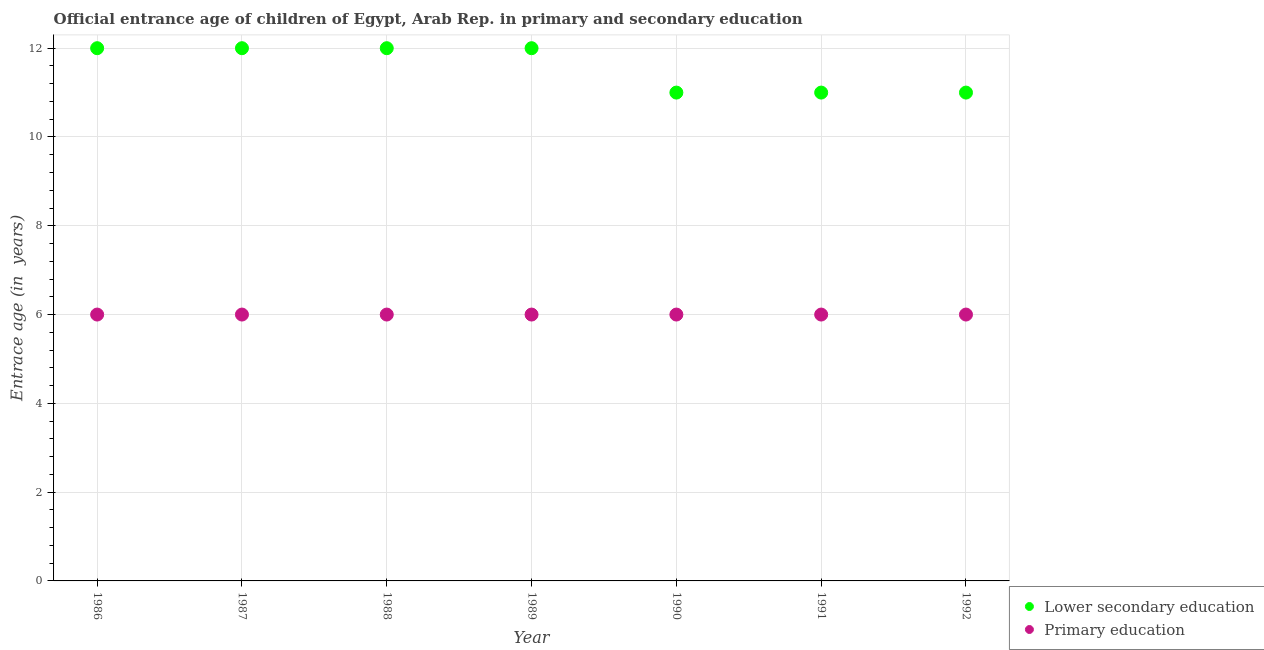Is the number of dotlines equal to the number of legend labels?
Offer a terse response. Yes. Across all years, what is the maximum entrance age of chiildren in primary education?
Your answer should be compact. 6. Across all years, what is the minimum entrance age of chiildren in primary education?
Your response must be concise. 6. In which year was the entrance age of chiildren in primary education maximum?
Provide a short and direct response. 1986. In which year was the entrance age of children in lower secondary education minimum?
Offer a terse response. 1990. What is the total entrance age of chiildren in primary education in the graph?
Ensure brevity in your answer.  42. What is the difference between the entrance age of chiildren in primary education in 1991 and the entrance age of children in lower secondary education in 1992?
Your answer should be compact. -5. What is the average entrance age of children in lower secondary education per year?
Provide a succinct answer. 11.57. In the year 1987, what is the difference between the entrance age of chiildren in primary education and entrance age of children in lower secondary education?
Offer a terse response. -6. In how many years, is the entrance age of chiildren in primary education greater than 1.6 years?
Offer a very short reply. 7. What is the ratio of the entrance age of children in lower secondary education in 1987 to that in 1992?
Offer a very short reply. 1.09. What is the difference between the highest and the second highest entrance age of chiildren in primary education?
Make the answer very short. 0. What is the difference between the highest and the lowest entrance age of children in lower secondary education?
Provide a succinct answer. 1. Is the entrance age of children in lower secondary education strictly greater than the entrance age of chiildren in primary education over the years?
Your answer should be compact. Yes. How many dotlines are there?
Provide a short and direct response. 2. Are the values on the major ticks of Y-axis written in scientific E-notation?
Keep it short and to the point. No. Does the graph contain any zero values?
Offer a very short reply. No. Where does the legend appear in the graph?
Ensure brevity in your answer.  Bottom right. How many legend labels are there?
Offer a terse response. 2. How are the legend labels stacked?
Your answer should be very brief. Vertical. What is the title of the graph?
Offer a very short reply. Official entrance age of children of Egypt, Arab Rep. in primary and secondary education. What is the label or title of the Y-axis?
Provide a succinct answer. Entrace age (in  years). What is the Entrace age (in  years) of Lower secondary education in 1986?
Make the answer very short. 12. What is the Entrace age (in  years) of Primary education in 1987?
Give a very brief answer. 6. What is the Entrace age (in  years) of Lower secondary education in 1989?
Your answer should be very brief. 12. What is the Entrace age (in  years) in Primary education in 1989?
Provide a short and direct response. 6. What is the Entrace age (in  years) of Lower secondary education in 1990?
Make the answer very short. 11. What is the Entrace age (in  years) of Lower secondary education in 1991?
Make the answer very short. 11. What is the Entrace age (in  years) in Lower secondary education in 1992?
Make the answer very short. 11. Across all years, what is the maximum Entrace age (in  years) in Lower secondary education?
Keep it short and to the point. 12. Across all years, what is the maximum Entrace age (in  years) of Primary education?
Offer a terse response. 6. Across all years, what is the minimum Entrace age (in  years) in Lower secondary education?
Ensure brevity in your answer.  11. What is the total Entrace age (in  years) in Primary education in the graph?
Offer a very short reply. 42. What is the difference between the Entrace age (in  years) in Lower secondary education in 1986 and that in 1987?
Provide a succinct answer. 0. What is the difference between the Entrace age (in  years) of Primary education in 1986 and that in 1988?
Keep it short and to the point. 0. What is the difference between the Entrace age (in  years) in Lower secondary education in 1986 and that in 1989?
Make the answer very short. 0. What is the difference between the Entrace age (in  years) in Primary education in 1986 and that in 1990?
Provide a short and direct response. 0. What is the difference between the Entrace age (in  years) in Lower secondary education in 1986 and that in 1991?
Your answer should be compact. 1. What is the difference between the Entrace age (in  years) of Lower secondary education in 1987 and that in 1988?
Your answer should be compact. 0. What is the difference between the Entrace age (in  years) in Primary education in 1987 and that in 1988?
Give a very brief answer. 0. What is the difference between the Entrace age (in  years) of Primary education in 1987 and that in 1989?
Provide a succinct answer. 0. What is the difference between the Entrace age (in  years) of Lower secondary education in 1987 and that in 1990?
Your answer should be compact. 1. What is the difference between the Entrace age (in  years) of Primary education in 1987 and that in 1990?
Provide a short and direct response. 0. What is the difference between the Entrace age (in  years) of Lower secondary education in 1987 and that in 1991?
Your answer should be compact. 1. What is the difference between the Entrace age (in  years) in Lower secondary education in 1987 and that in 1992?
Your answer should be very brief. 1. What is the difference between the Entrace age (in  years) of Lower secondary education in 1988 and that in 1989?
Make the answer very short. 0. What is the difference between the Entrace age (in  years) of Primary education in 1988 and that in 1989?
Keep it short and to the point. 0. What is the difference between the Entrace age (in  years) of Lower secondary education in 1988 and that in 1991?
Offer a very short reply. 1. What is the difference between the Entrace age (in  years) in Lower secondary education in 1988 and that in 1992?
Your answer should be very brief. 1. What is the difference between the Entrace age (in  years) in Primary education in 1988 and that in 1992?
Your response must be concise. 0. What is the difference between the Entrace age (in  years) in Primary education in 1989 and that in 1990?
Offer a very short reply. 0. What is the difference between the Entrace age (in  years) in Primary education in 1989 and that in 1992?
Your answer should be very brief. 0. What is the difference between the Entrace age (in  years) of Lower secondary education in 1990 and that in 1991?
Make the answer very short. 0. What is the difference between the Entrace age (in  years) of Primary education in 1990 and that in 1991?
Ensure brevity in your answer.  0. What is the difference between the Entrace age (in  years) of Primary education in 1990 and that in 1992?
Offer a terse response. 0. What is the difference between the Entrace age (in  years) in Primary education in 1991 and that in 1992?
Offer a very short reply. 0. What is the difference between the Entrace age (in  years) of Lower secondary education in 1986 and the Entrace age (in  years) of Primary education in 1987?
Offer a very short reply. 6. What is the difference between the Entrace age (in  years) in Lower secondary education in 1986 and the Entrace age (in  years) in Primary education in 1988?
Offer a terse response. 6. What is the difference between the Entrace age (in  years) of Lower secondary education in 1986 and the Entrace age (in  years) of Primary education in 1989?
Your answer should be compact. 6. What is the difference between the Entrace age (in  years) in Lower secondary education in 1986 and the Entrace age (in  years) in Primary education in 1990?
Offer a terse response. 6. What is the difference between the Entrace age (in  years) in Lower secondary education in 1986 and the Entrace age (in  years) in Primary education in 1991?
Offer a very short reply. 6. What is the difference between the Entrace age (in  years) of Lower secondary education in 1987 and the Entrace age (in  years) of Primary education in 1988?
Ensure brevity in your answer.  6. What is the difference between the Entrace age (in  years) of Lower secondary education in 1987 and the Entrace age (in  years) of Primary education in 1989?
Your response must be concise. 6. What is the difference between the Entrace age (in  years) of Lower secondary education in 1987 and the Entrace age (in  years) of Primary education in 1992?
Your answer should be very brief. 6. What is the difference between the Entrace age (in  years) in Lower secondary education in 1990 and the Entrace age (in  years) in Primary education in 1992?
Ensure brevity in your answer.  5. What is the difference between the Entrace age (in  years) in Lower secondary education in 1991 and the Entrace age (in  years) in Primary education in 1992?
Make the answer very short. 5. What is the average Entrace age (in  years) in Lower secondary education per year?
Offer a terse response. 11.57. In the year 1986, what is the difference between the Entrace age (in  years) of Lower secondary education and Entrace age (in  years) of Primary education?
Make the answer very short. 6. In the year 1988, what is the difference between the Entrace age (in  years) in Lower secondary education and Entrace age (in  years) in Primary education?
Your answer should be very brief. 6. In the year 1989, what is the difference between the Entrace age (in  years) in Lower secondary education and Entrace age (in  years) in Primary education?
Provide a short and direct response. 6. What is the ratio of the Entrace age (in  years) in Primary education in 1986 to that in 1987?
Your response must be concise. 1. What is the ratio of the Entrace age (in  years) of Lower secondary education in 1986 to that in 1988?
Your answer should be very brief. 1. What is the ratio of the Entrace age (in  years) of Primary education in 1986 to that in 1988?
Your answer should be compact. 1. What is the ratio of the Entrace age (in  years) in Lower secondary education in 1986 to that in 1989?
Keep it short and to the point. 1. What is the ratio of the Entrace age (in  years) in Primary education in 1986 to that in 1989?
Offer a terse response. 1. What is the ratio of the Entrace age (in  years) of Lower secondary education in 1986 to that in 1990?
Your answer should be compact. 1.09. What is the ratio of the Entrace age (in  years) of Primary education in 1986 to that in 1990?
Ensure brevity in your answer.  1. What is the ratio of the Entrace age (in  years) in Lower secondary education in 1986 to that in 1991?
Your answer should be very brief. 1.09. What is the ratio of the Entrace age (in  years) of Primary education in 1986 to that in 1991?
Your answer should be very brief. 1. What is the ratio of the Entrace age (in  years) of Lower secondary education in 1986 to that in 1992?
Ensure brevity in your answer.  1.09. What is the ratio of the Entrace age (in  years) of Lower secondary education in 1987 to that in 1989?
Ensure brevity in your answer.  1. What is the ratio of the Entrace age (in  years) of Lower secondary education in 1987 to that in 1990?
Provide a succinct answer. 1.09. What is the ratio of the Entrace age (in  years) of Primary education in 1987 to that in 1990?
Offer a terse response. 1. What is the ratio of the Entrace age (in  years) of Lower secondary education in 1987 to that in 1992?
Keep it short and to the point. 1.09. What is the ratio of the Entrace age (in  years) in Primary education in 1987 to that in 1992?
Your response must be concise. 1. What is the ratio of the Entrace age (in  years) in Primary education in 1988 to that in 1989?
Offer a terse response. 1. What is the ratio of the Entrace age (in  years) of Lower secondary education in 1988 to that in 1990?
Your response must be concise. 1.09. What is the ratio of the Entrace age (in  years) in Primary education in 1988 to that in 1990?
Offer a very short reply. 1. What is the ratio of the Entrace age (in  years) of Primary education in 1988 to that in 1991?
Ensure brevity in your answer.  1. What is the ratio of the Entrace age (in  years) of Lower secondary education in 1988 to that in 1992?
Ensure brevity in your answer.  1.09. What is the ratio of the Entrace age (in  years) in Primary education in 1989 to that in 1990?
Provide a succinct answer. 1. What is the ratio of the Entrace age (in  years) of Lower secondary education in 1989 to that in 1991?
Your answer should be very brief. 1.09. What is the ratio of the Entrace age (in  years) in Primary education in 1989 to that in 1991?
Offer a terse response. 1. What is the ratio of the Entrace age (in  years) in Lower secondary education in 1989 to that in 1992?
Provide a succinct answer. 1.09. What is the difference between the highest and the second highest Entrace age (in  years) of Lower secondary education?
Your answer should be very brief. 0. What is the difference between the highest and the lowest Entrace age (in  years) in Lower secondary education?
Make the answer very short. 1. What is the difference between the highest and the lowest Entrace age (in  years) in Primary education?
Offer a very short reply. 0. 